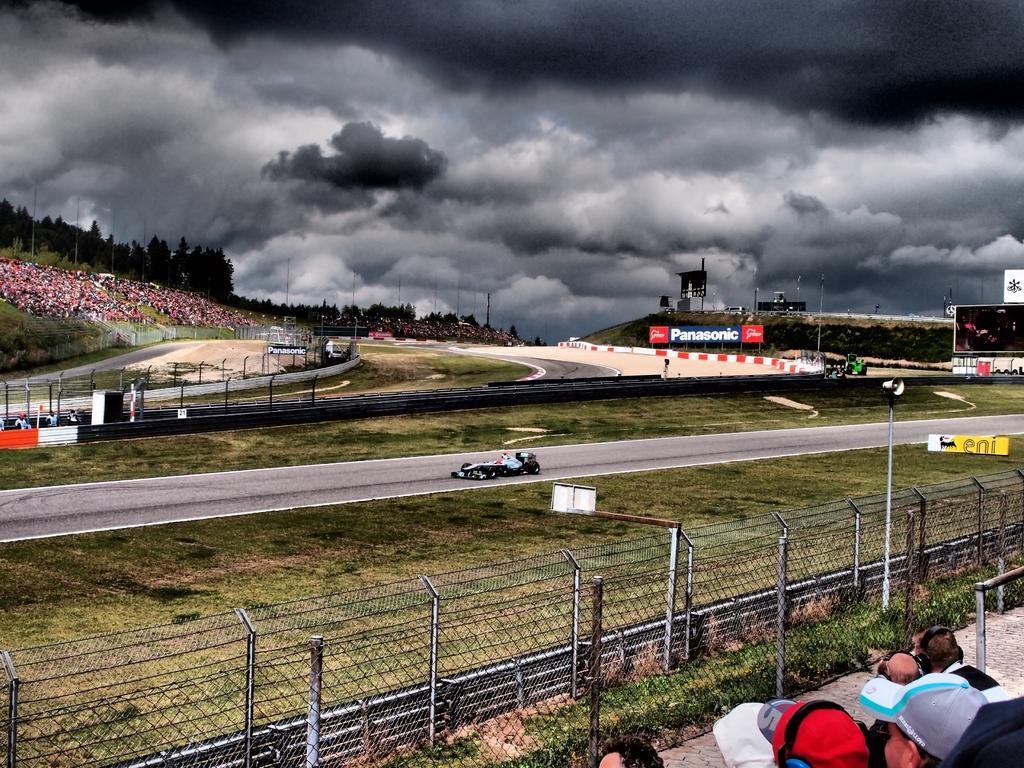Could you give a brief overview of what you see in this image? In this picture we can see there are groups of people sitting. In front of the people there are fences, boards, grass and hoardings. There is a sports car on the road. Behind the people there are poles, trees and the cloudy sky. 